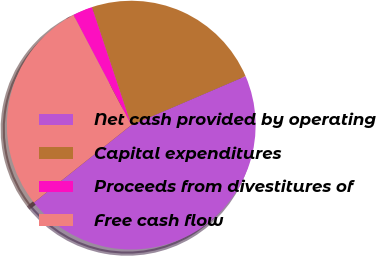<chart> <loc_0><loc_0><loc_500><loc_500><pie_chart><fcel>Net cash provided by operating<fcel>Capital expenditures<fcel>Proceeds from divestitures of<fcel>Free cash flow<nl><fcel>45.75%<fcel>23.68%<fcel>2.57%<fcel>28.0%<nl></chart> 